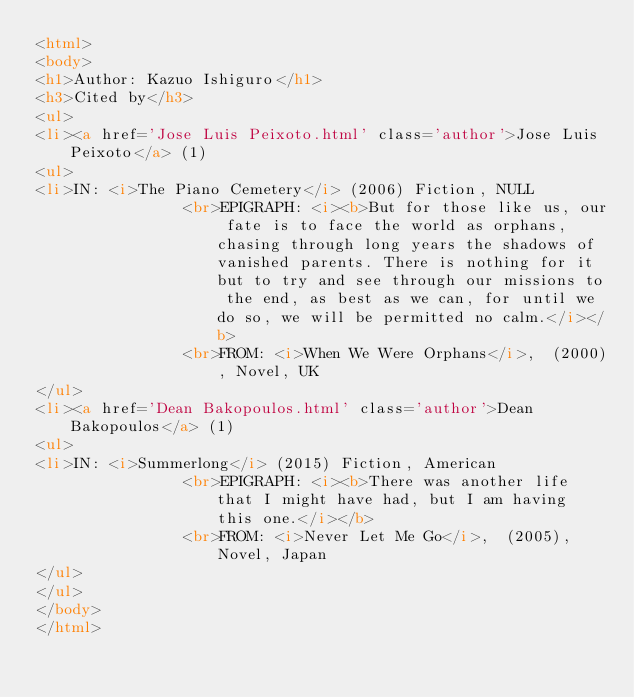Convert code to text. <code><loc_0><loc_0><loc_500><loc_500><_HTML_><html>
<body>
<h1>Author: Kazuo Ishiguro</h1>
<h3>Cited by</h3>
<ul>
<li><a href='Jose Luis Peixoto.html' class='author'>Jose Luis Peixoto</a> (1)
<ul>
<li>IN: <i>The Piano Cemetery</i> (2006) Fiction, NULL
                <br>EPIGRAPH: <i><b>But for those like us, our fate is to face the world as orphans, chasing through long years the shadows of vanished parents. There is nothing for it but to try and see through our missions to the end, as best as we can, for until we do so, we will be permitted no calm.</i></b>
                <br>FROM: <i>When We Were Orphans</i>,  (2000), Novel, UK
</ul>
<li><a href='Dean Bakopoulos.html' class='author'>Dean Bakopoulos</a> (1)
<ul>
<li>IN: <i>Summerlong</i> (2015) Fiction, American
                <br>EPIGRAPH: <i><b>There was another life that I might have had, but I am having this one.</i></b>
                <br>FROM: <i>Never Let Me Go</i>,  (2005), Novel, Japan
</ul>
</ul>
</body>
</html>
</code> 